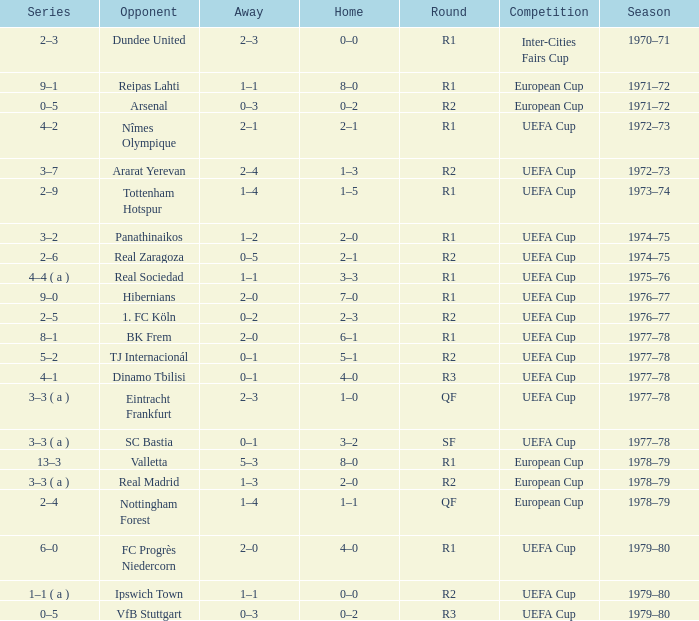Which Home has a Competition of european cup, and a Round of qf? 1–1. 